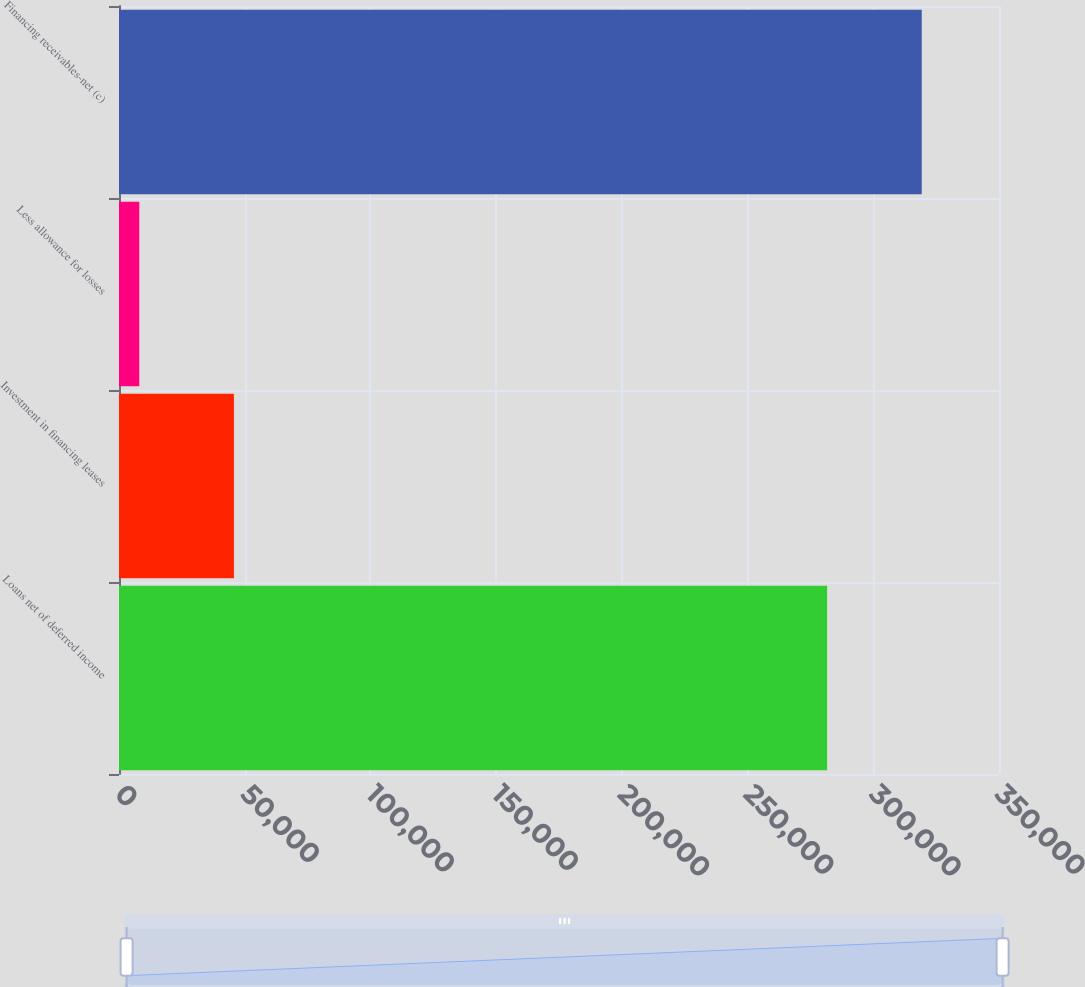Convert chart. <chart><loc_0><loc_0><loc_500><loc_500><bar_chart><fcel>Loans net of deferred income<fcel>Investment in financing leases<fcel>Less allowance for losses<fcel>Financing receivables-net (c)<nl><fcel>281639<fcel>45710<fcel>8072<fcel>319277<nl></chart> 